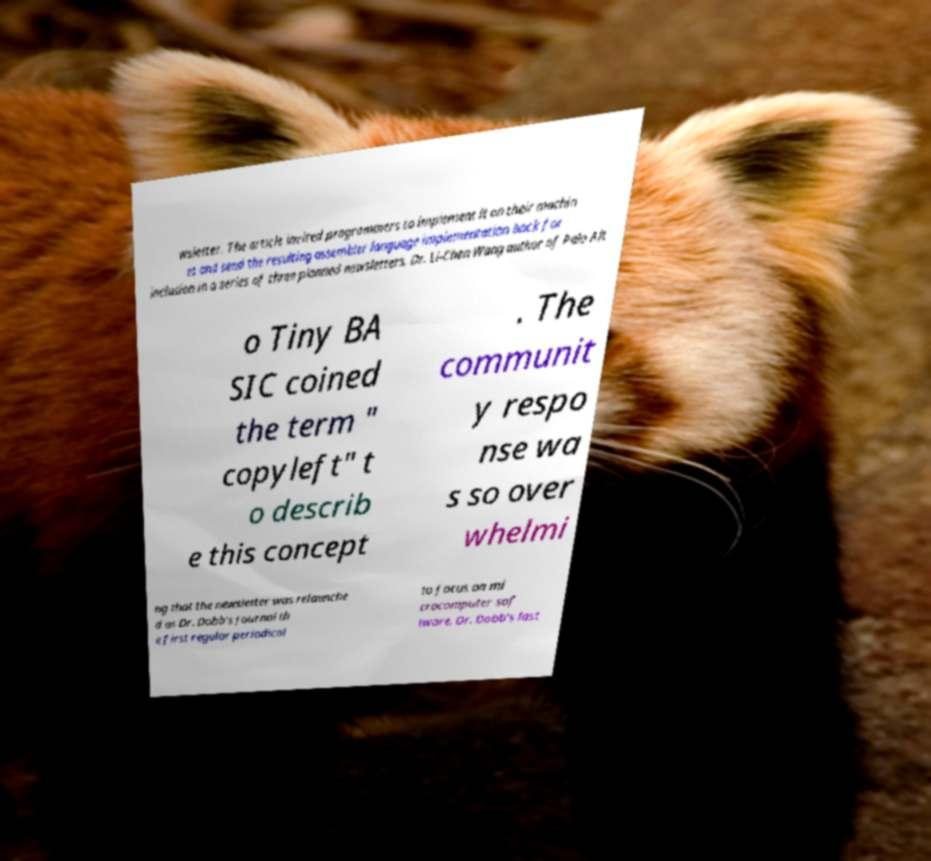There's text embedded in this image that I need extracted. Can you transcribe it verbatim? wsletter. The article invited programmers to implement it on their machin es and send the resulting assembler language implementation back for inclusion in a series of three planned newsletters. Dr. Li-Chen Wang author of Palo Alt o Tiny BA SIC coined the term " copyleft" t o describ e this concept . The communit y respo nse wa s so over whelmi ng that the newsletter was relaunche d as Dr. Dobb's Journal th e first regular periodical to focus on mi crocomputer sof tware. Dr. Dobb's last 